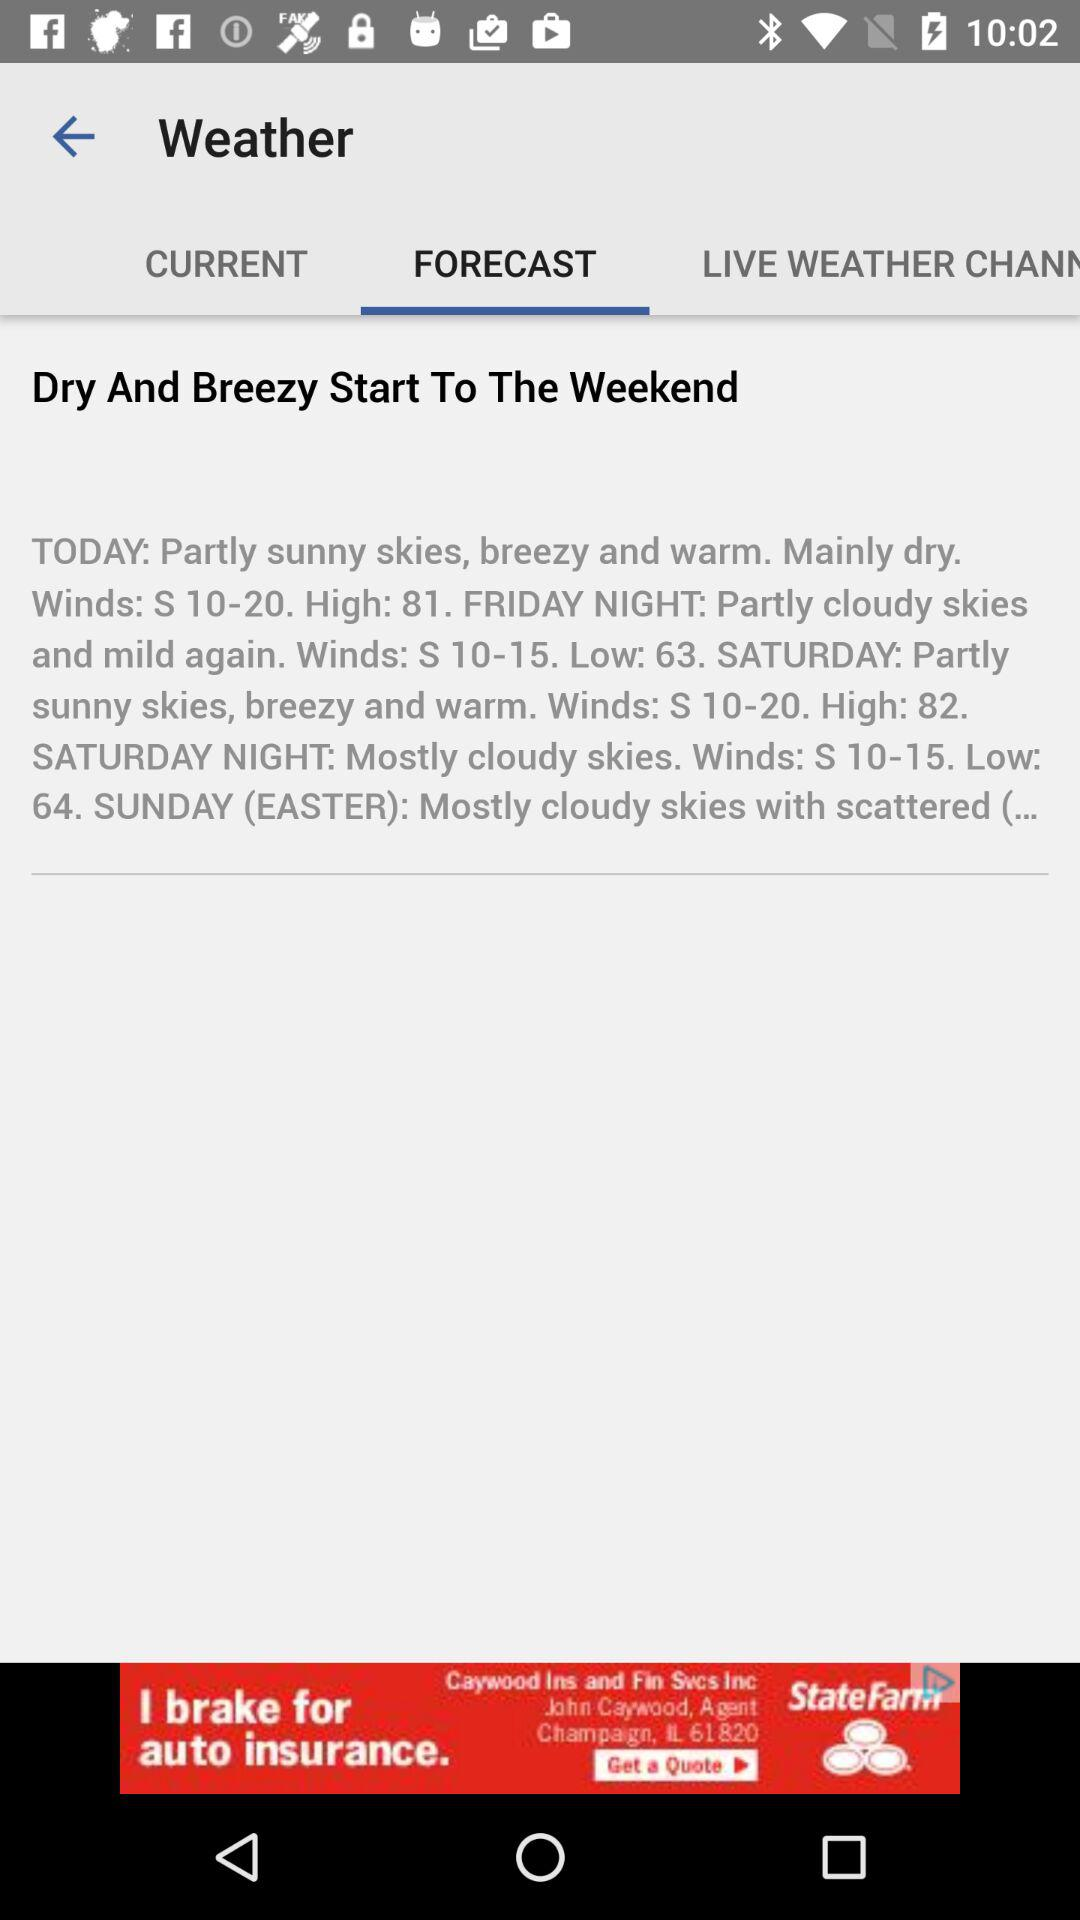What is the wind speed?
When the provided information is insufficient, respond with <no answer>. <no answer> 